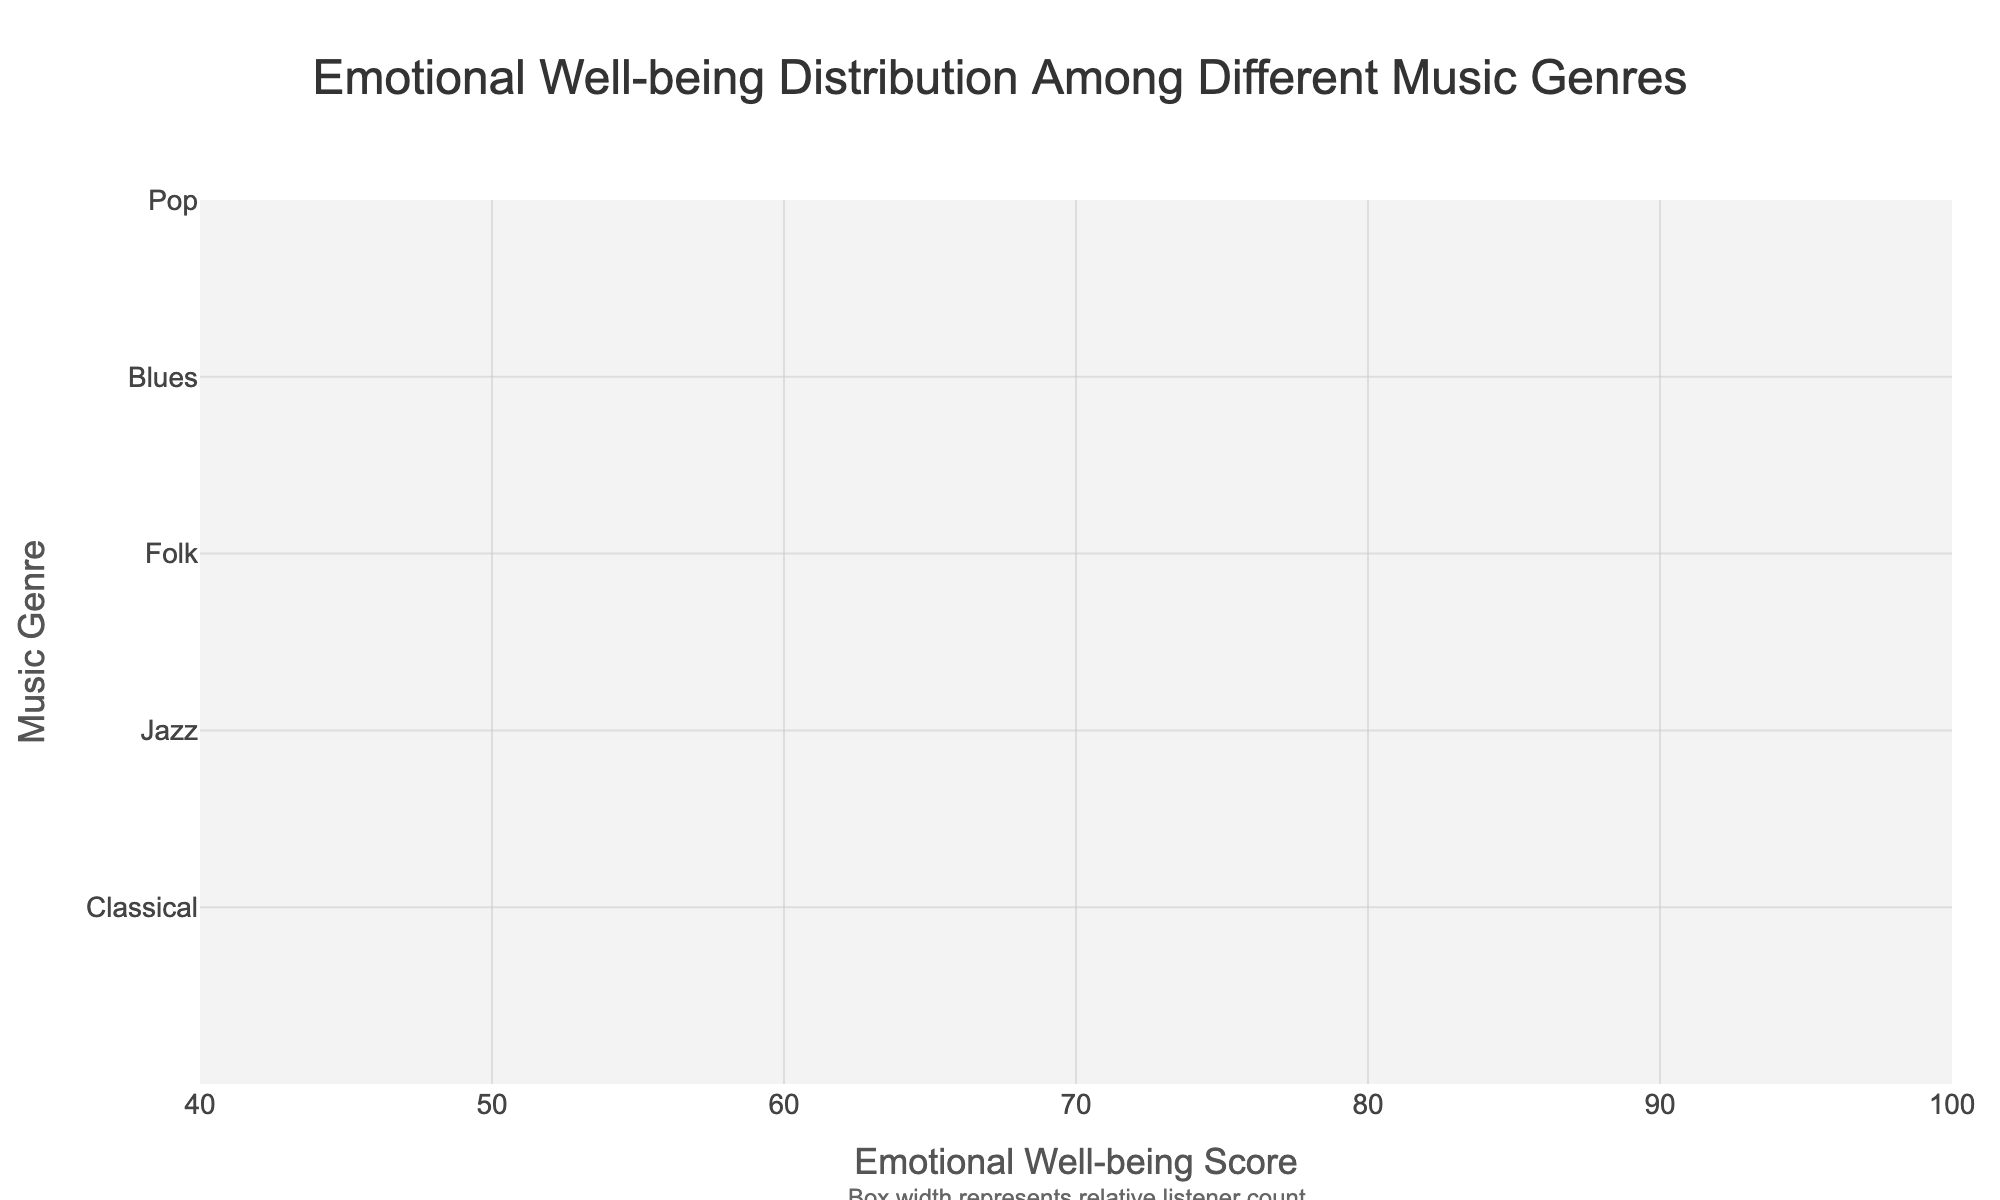What is the title of the plot? The plot's title is displayed at the top center of the figure.
Answer: Emotional Well-being Distribution Among Different Music Genres Which genre has the widest box plot? The width of the box plot represents the relative listener count. The widest box is for the genre that has the highest listener count.
Answer: Pop What is the median emotional well-being score for Blues? The median score is represented by the line inside the box plot for Blues.
Answer: 78 Compare the median emotional well-being scores of Pop and Classical. Which is higher? According to the plot, the median score for Classical is higher than that for Pop.
Answer: Classical What is the interquartile range (IQR) for Jazz? The IQR is calculated as Q3 - Q1 for Jazz. From the plot, Q3 is 85 and Q1 is 70.
Answer: 15 Which genre has the lowest median emotional well-being score? The genre with the lowest line inside its box plot represents the lowest median score.
Answer: Hip Hop How does the median emotional well-being score of Rock compare to the mean score of Electronic? The plot shows the median score for Rock and the mean score for Electronic. The median for Rock should be compared numerically to the mean for Electronic (Rock median = 68, Electronic mean = 62).
Answer: Higher What is the range of emotional well-being scores for Classical genre (from lower fence to upper fence)? The lower fence and upper fence can be derived as Q1 - 1.5 * IQR and Q3 + 1.5 * IQR for Classical. Q1 = 75, Q3 = 90, IQR = 15. Lower fence = 75 - 22.5 = 52.5, Upper fence = 97.5.
Answer: 52.5 to 97.5 Why might Jazz have a narrower box plot than Pop, despite having a higher emotional well-being mean? The width of the box plot is determined by the relative listener count, not by the emotional well-being score. So, although Jazz has a higher mean, Pop has more listeners.
Answer: Pop has more listeners than Jazz Identify the genre with the least variability in emotional well-being scores and explain how you determined this. The genre with the least variability will have the smallest IQR (difference between Q3 and Q1). By visually comparing the lengths of the boxes, we can determine this. From the plot, Pop's IQR (78 - 65) = 13, which seems to be the smallest.
Answer: Pop 